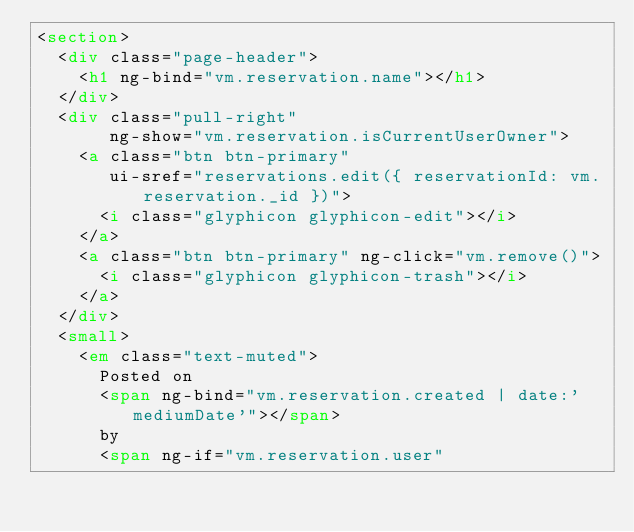<code> <loc_0><loc_0><loc_500><loc_500><_HTML_><section>
  <div class="page-header">
    <h1 ng-bind="vm.reservation.name"></h1>
  </div>
  <div class="pull-right"
       ng-show="vm.reservation.isCurrentUserOwner">
    <a class="btn btn-primary"
       ui-sref="reservations.edit({ reservationId: vm.reservation._id })">
      <i class="glyphicon glyphicon-edit"></i>
    </a>
    <a class="btn btn-primary" ng-click="vm.remove()">
      <i class="glyphicon glyphicon-trash"></i>
    </a>
  </div>
  <small>
    <em class="text-muted">
      Posted on
      <span ng-bind="vm.reservation.created | date:'mediumDate'"></span>
      by
      <span ng-if="vm.reservation.user"</code> 